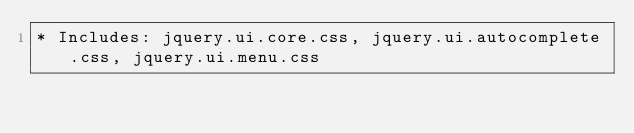<code> <loc_0><loc_0><loc_500><loc_500><_CSS_>* Includes: jquery.ui.core.css, jquery.ui.autocomplete.css, jquery.ui.menu.css</code> 